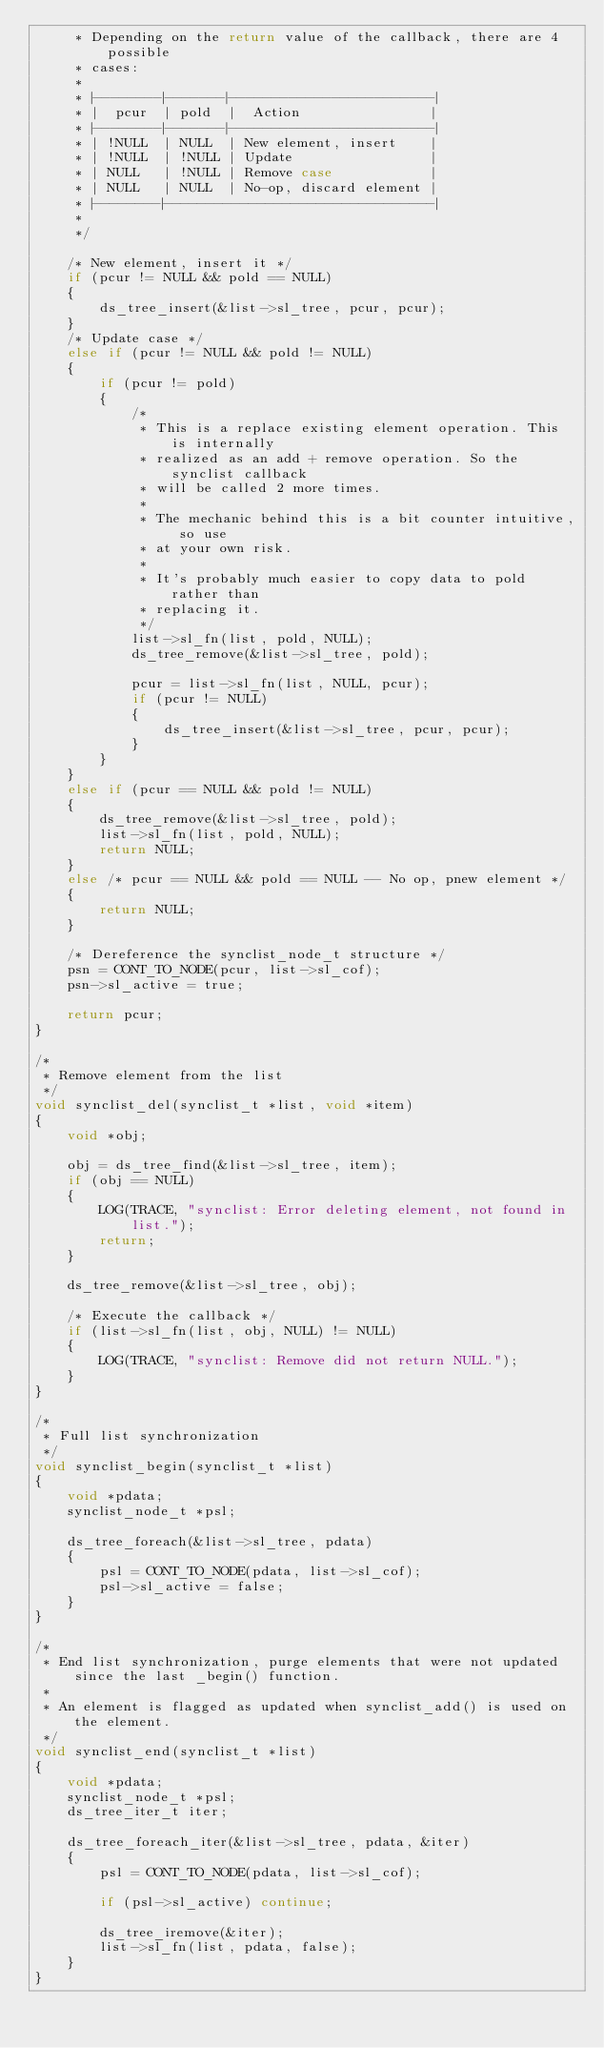Convert code to text. <code><loc_0><loc_0><loc_500><loc_500><_C_>     * Depending on the return value of the callback, there are 4 possible
     * cases:
     *
     * |--------|-------|------------------------|
     * |  pcur  | pold  |  Action                |
     * |--------|-------|------------------------|
     * | !NULL  | NULL  | New element, insert    |
     * | !NULL  | !NULL | Update                 |
     * | NULL   | !NULL | Remove case            |
     * | NULL   | NULL  | No-op, discard element |
     * |--------|--------------------------------|
     *
     */

    /* New element, insert it */
    if (pcur != NULL && pold == NULL)
    {
        ds_tree_insert(&list->sl_tree, pcur, pcur);
    }
    /* Update case */
    else if (pcur != NULL && pold != NULL)
    {
        if (pcur != pold)
        {
            /*
             * This is a replace existing element operation. This is internally
             * realized as an add + remove operation. So the synclist callback
             * will be called 2 more times.
             *
             * The mechanic behind this is a bit counter intuitive, so use
             * at your own risk.
             *
             * It's probably much easier to copy data to pold rather than
             * replacing it.
             */
            list->sl_fn(list, pold, NULL);
            ds_tree_remove(&list->sl_tree, pold);

            pcur = list->sl_fn(list, NULL, pcur);
            if (pcur != NULL)
            {
                ds_tree_insert(&list->sl_tree, pcur, pcur);
            }
        }
    }
    else if (pcur == NULL && pold != NULL)
    {
        ds_tree_remove(&list->sl_tree, pold);
        list->sl_fn(list, pold, NULL);
        return NULL;
    }
    else /* pcur == NULL && pold == NULL -- No op, pnew element */
    {
        return NULL;
    }

    /* Dereference the synclist_node_t structure */
    psn = CONT_TO_NODE(pcur, list->sl_cof);
    psn->sl_active = true;

    return pcur;
}

/*
 * Remove element from the list
 */
void synclist_del(synclist_t *list, void *item)
{
    void *obj;

    obj = ds_tree_find(&list->sl_tree, item);
    if (obj == NULL)
    {
        LOG(TRACE, "synclist: Error deleting element, not found in list.");
        return;
    }

    ds_tree_remove(&list->sl_tree, obj);

    /* Execute the callback */
    if (list->sl_fn(list, obj, NULL) != NULL)
    {
        LOG(TRACE, "synclist: Remove did not return NULL.");
    }
}

/*
 * Full list synchronization
 */
void synclist_begin(synclist_t *list)
{
    void *pdata;
    synclist_node_t *psl;

    ds_tree_foreach(&list->sl_tree, pdata)
    {
        psl = CONT_TO_NODE(pdata, list->sl_cof);
        psl->sl_active = false;
    }
}

/*
 * End list synchronization, purge elements that were not updated since the last _begin() function.
 *
 * An element is flagged as updated when synclist_add() is used on the element.
 */
void synclist_end(synclist_t *list)
{
    void *pdata;
    synclist_node_t *psl;
    ds_tree_iter_t iter;

    ds_tree_foreach_iter(&list->sl_tree, pdata, &iter)
    {
        psl = CONT_TO_NODE(pdata, list->sl_cof);

        if (psl->sl_active) continue;

        ds_tree_iremove(&iter);
        list->sl_fn(list, pdata, false);
    }
}
</code> 